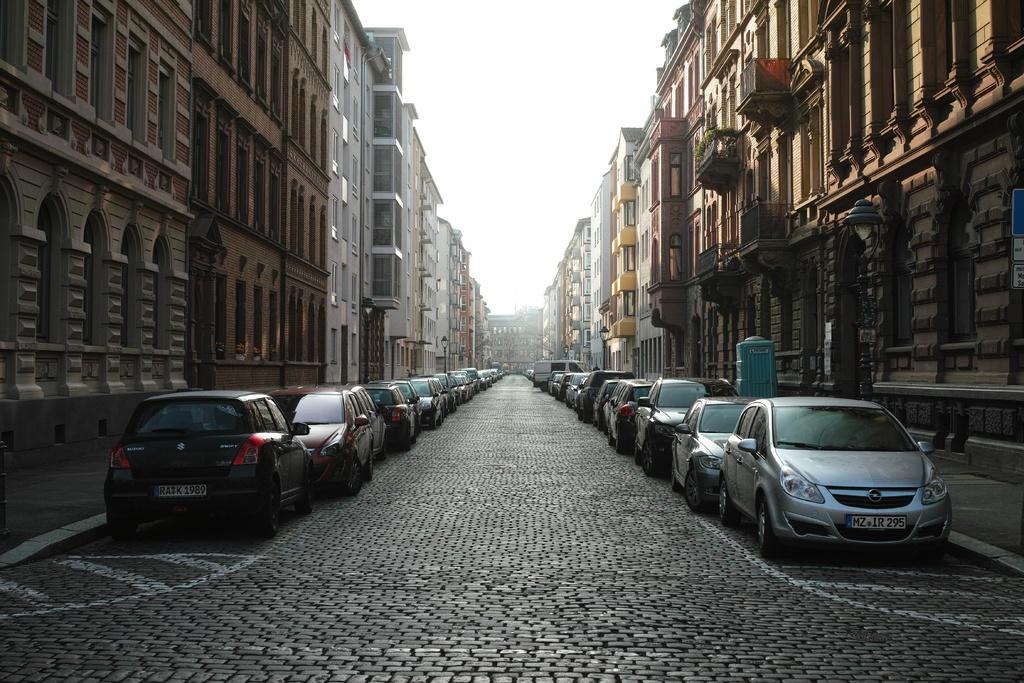In one or two sentences, can you explain what this image depicts? Many cars are parked. There are buildings on the either sides of the road. 